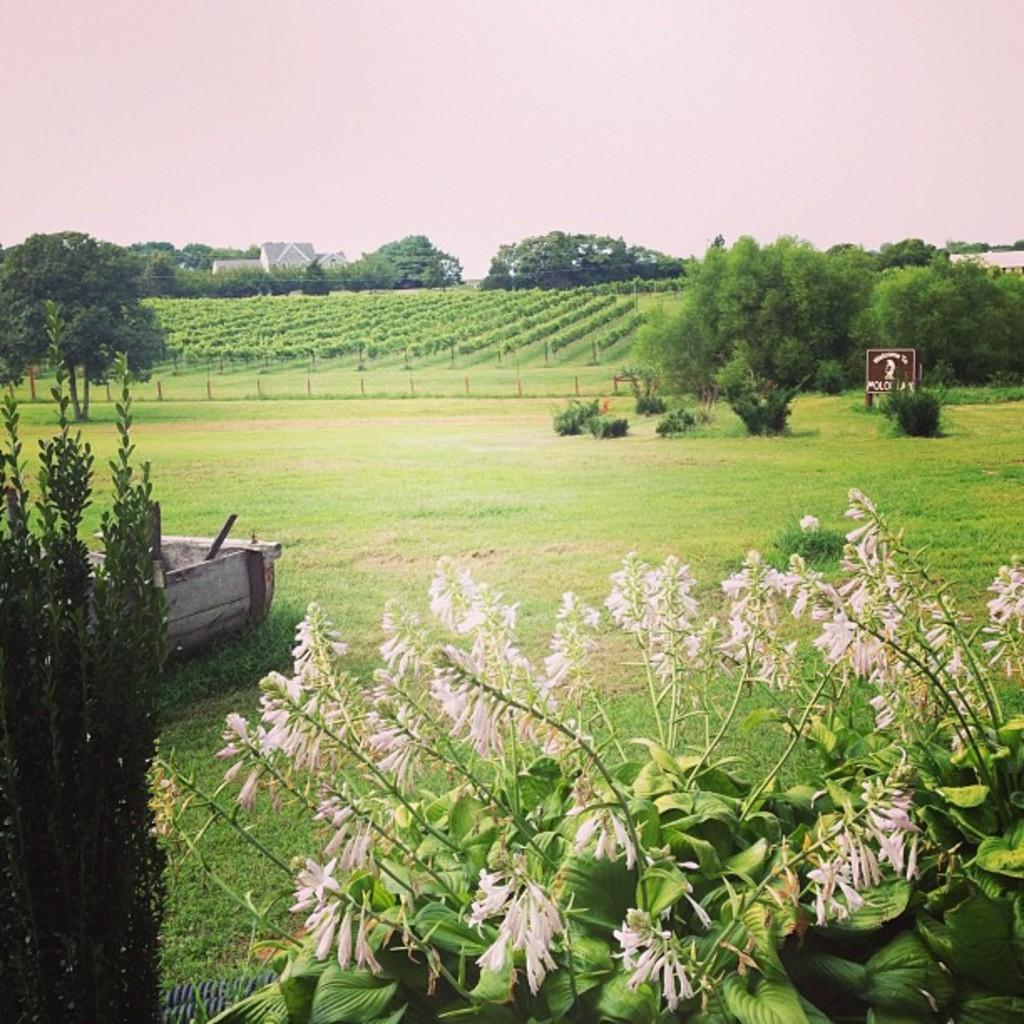Please provide a concise description of this image. In the center of the image we can see the sky,trees,one building,plants,grass,fences,flowers,one sign board,on wooden object and few other objects. 